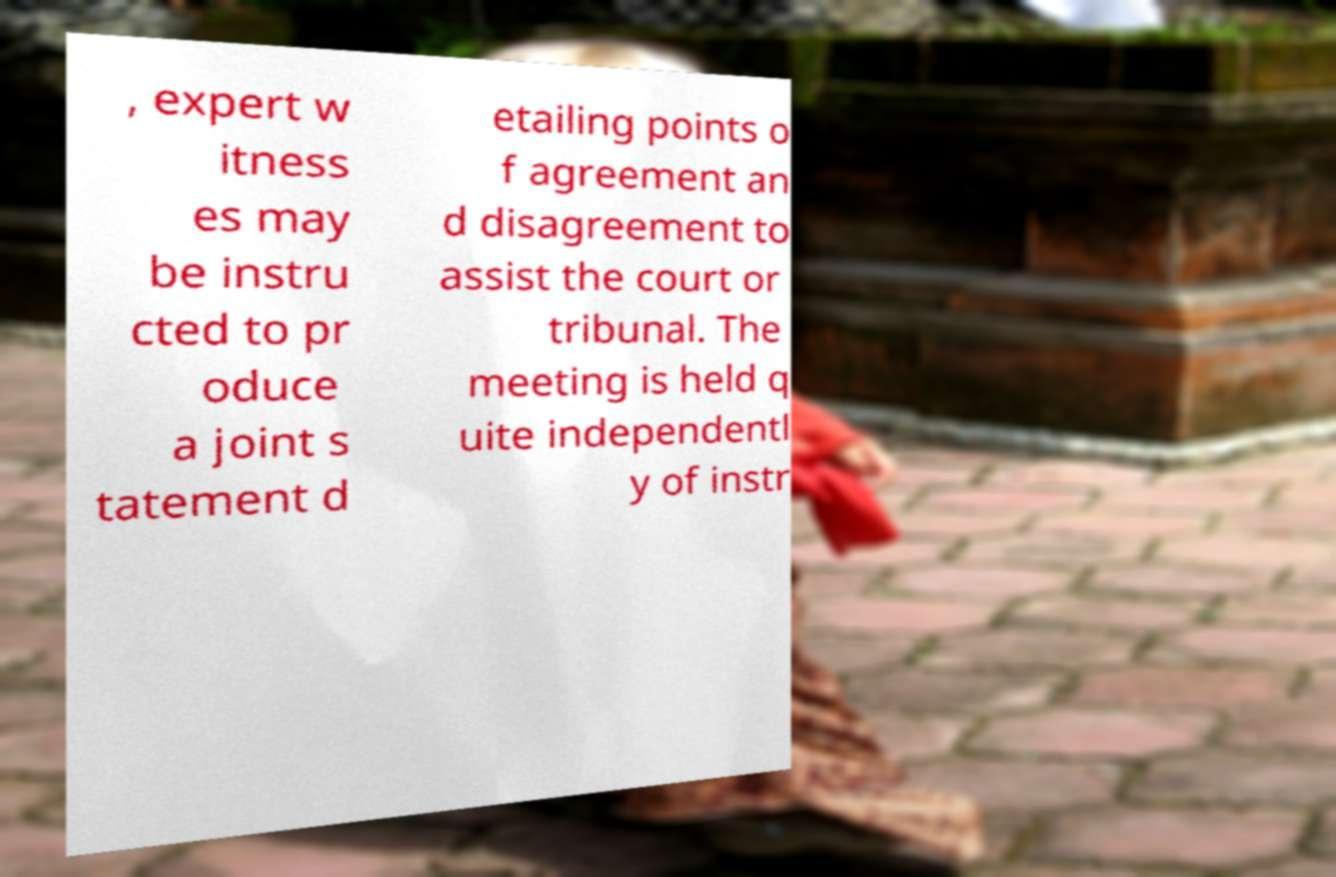Please read and relay the text visible in this image. What does it say? , expert w itness es may be instru cted to pr oduce a joint s tatement d etailing points o f agreement an d disagreement to assist the court or tribunal. The meeting is held q uite independentl y of instr 